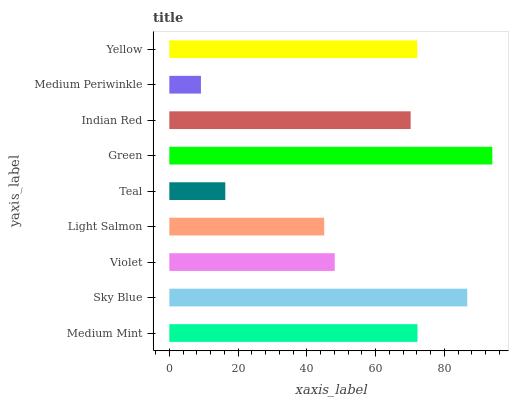Is Medium Periwinkle the minimum?
Answer yes or no. Yes. Is Green the maximum?
Answer yes or no. Yes. Is Sky Blue the minimum?
Answer yes or no. No. Is Sky Blue the maximum?
Answer yes or no. No. Is Sky Blue greater than Medium Mint?
Answer yes or no. Yes. Is Medium Mint less than Sky Blue?
Answer yes or no. Yes. Is Medium Mint greater than Sky Blue?
Answer yes or no. No. Is Sky Blue less than Medium Mint?
Answer yes or no. No. Is Indian Red the high median?
Answer yes or no. Yes. Is Indian Red the low median?
Answer yes or no. Yes. Is Medium Mint the high median?
Answer yes or no. No. Is Yellow the low median?
Answer yes or no. No. 